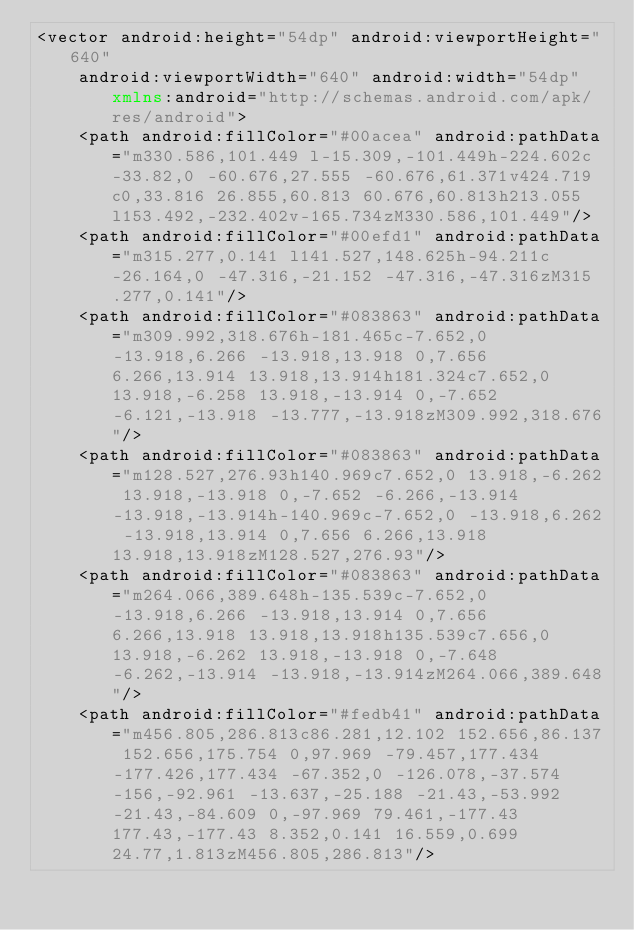Convert code to text. <code><loc_0><loc_0><loc_500><loc_500><_XML_><vector android:height="54dp" android:viewportHeight="640"
    android:viewportWidth="640" android:width="54dp" xmlns:android="http://schemas.android.com/apk/res/android">
    <path android:fillColor="#00acea" android:pathData="m330.586,101.449 l-15.309,-101.449h-224.602c-33.82,0 -60.676,27.555 -60.676,61.371v424.719c0,33.816 26.855,60.813 60.676,60.813h213.055l153.492,-232.402v-165.734zM330.586,101.449"/>
    <path android:fillColor="#00efd1" android:pathData="m315.277,0.141 l141.527,148.625h-94.211c-26.164,0 -47.316,-21.152 -47.316,-47.316zM315.277,0.141"/>
    <path android:fillColor="#083863" android:pathData="m309.992,318.676h-181.465c-7.652,0 -13.918,6.266 -13.918,13.918 0,7.656 6.266,13.914 13.918,13.914h181.324c7.652,0 13.918,-6.258 13.918,-13.914 0,-7.652 -6.121,-13.918 -13.777,-13.918zM309.992,318.676"/>
    <path android:fillColor="#083863" android:pathData="m128.527,276.93h140.969c7.652,0 13.918,-6.262 13.918,-13.918 0,-7.652 -6.266,-13.914 -13.918,-13.914h-140.969c-7.652,0 -13.918,6.262 -13.918,13.914 0,7.656 6.266,13.918 13.918,13.918zM128.527,276.93"/>
    <path android:fillColor="#083863" android:pathData="m264.066,389.648h-135.539c-7.652,0 -13.918,6.266 -13.918,13.914 0,7.656 6.266,13.918 13.918,13.918h135.539c7.656,0 13.918,-6.262 13.918,-13.918 0,-7.648 -6.262,-13.914 -13.918,-13.914zM264.066,389.648"/>
    <path android:fillColor="#fedb41" android:pathData="m456.805,286.813c86.281,12.102 152.656,86.137 152.656,175.754 0,97.969 -79.457,177.434 -177.426,177.434 -67.352,0 -126.078,-37.574 -156,-92.961 -13.637,-25.188 -21.43,-53.992 -21.43,-84.609 0,-97.969 79.461,-177.43 177.43,-177.43 8.352,0.141 16.559,0.699 24.77,1.813zM456.805,286.813"/></code> 